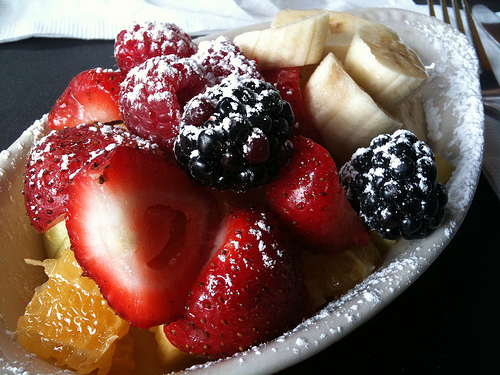<image>
Is there a banana next to the strawberry? Yes. The banana is positioned adjacent to the strawberry, located nearby in the same general area. 